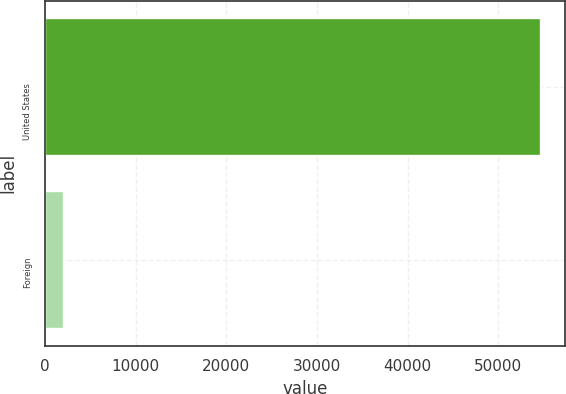<chart> <loc_0><loc_0><loc_500><loc_500><bar_chart><fcel>United States<fcel>Foreign<nl><fcel>54685<fcel>2085<nl></chart> 